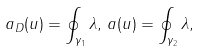<formula> <loc_0><loc_0><loc_500><loc_500>a _ { D } ( u ) = \oint _ { \gamma _ { 1 } } \lambda , \, a ( u ) = \oint _ { \gamma _ { 2 } } \lambda ,</formula> 